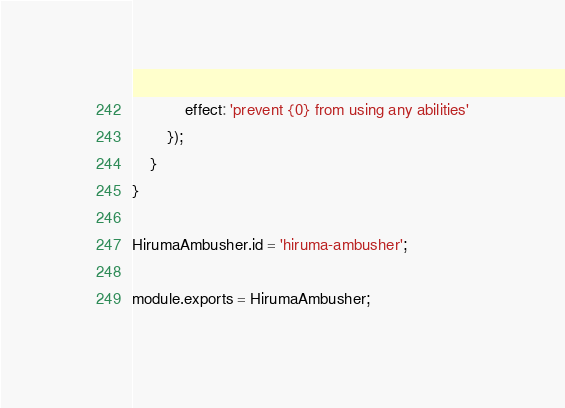Convert code to text. <code><loc_0><loc_0><loc_500><loc_500><_JavaScript_>            effect: 'prevent {0} from using any abilities'
        });
    }
}

HirumaAmbusher.id = 'hiruma-ambusher';

module.exports = HirumaAmbusher;
</code> 